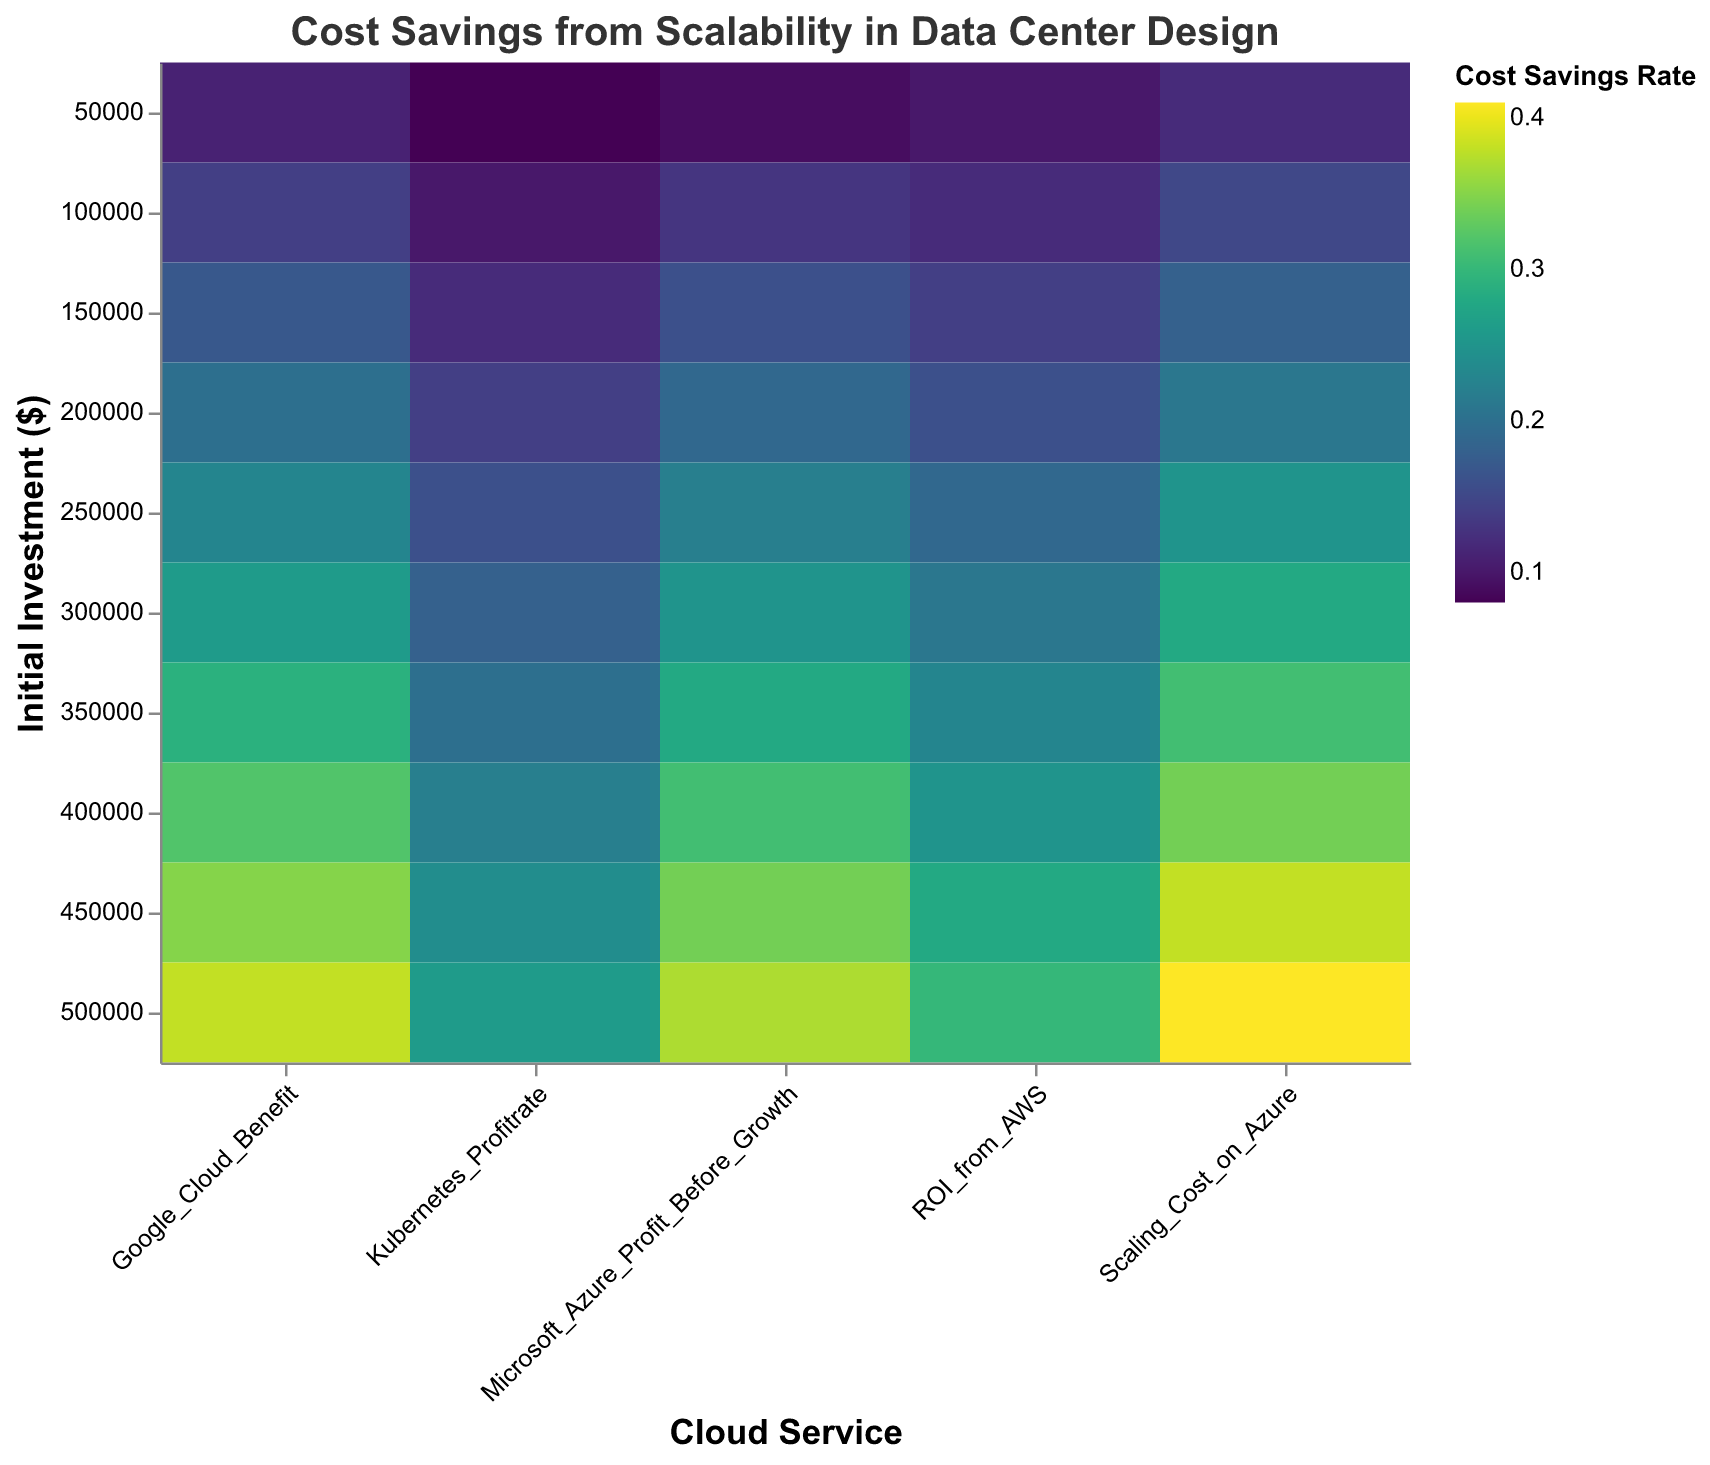What's the title of the heatmap? Look at the top of the figure, the title is usually displayed there.
Answer: "Cost Savings from Scalability in Data Center Design" How is the savings rate represented on the heatmap? Examine the color legend on the right of the heatmap, which shows cost savings rate.
Answer: By color gradient Which cloud service shows the highest cost savings rate for an initial investment of $500,000? Find the row with $500,000 on the y-axis and see which cell has the darkest color. This cell represents the highest savings rate.
Answer: Scaling Cost on Azure What is the range of initial investments shown in the heatmap? Inspect the y-axis to see the minimum and maximum initial investment values.
Answer: $50,000 to $500,000 Which cloud service has the lowest cost savings rate for an initial investment of $50,000? Locate the row with $50,000 on the y-axis and find the cell with the lightest color. This represents the lowest savings rate.
Answer: Microsoft Azure Profit Before Growth Compare the cost savings rate of Google Cloud Benefit and ROI from AWS for an initial investment of $300,000. Which is higher? Find the row with $300,000 and compare the colors in the Google Cloud Benefit and ROI from AWS columns. The darker color indicates a higher savings rate.
Answer: Google Cloud Benefit What is the general trend of cost savings rates as the initial investment increases? Observe the color pattern from top to bottom for any column. Notice whether the colors generally darken as you move down, indicating higher savings rates.
Answer: Increasing For an initial investment of $200,000, which cloud services have a higher cost savings rate than Kubernetes Profitrate? Locate the row with $200,000 and compare the color in the Kubernetes Profitrate column to the other columns. Identify the columns with darker colors.
Answer: ROI from AWS, Scaling Cost on Azure, Google Cloud Benefit, Microsoft Azure Profit Before Growth How are different cloud services visualized in the heatmap? The x-axis lists different cloud services, and their savings rates are represented by colored cells. The y-axis represents initial investment levels.
Answer: By different colored cells in columns Which cloud service shows the most significant increase in cost savings rate as the initial investment increases from $250,000 to $500,000? Compare the colors of the cells in each column between the investment levels of $250,000 and $500,000. Look for the column with the darkest color change.
Answer: Scaling Cost on Azure 